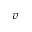<formula> <loc_0><loc_0><loc_500><loc_500>v</formula> 